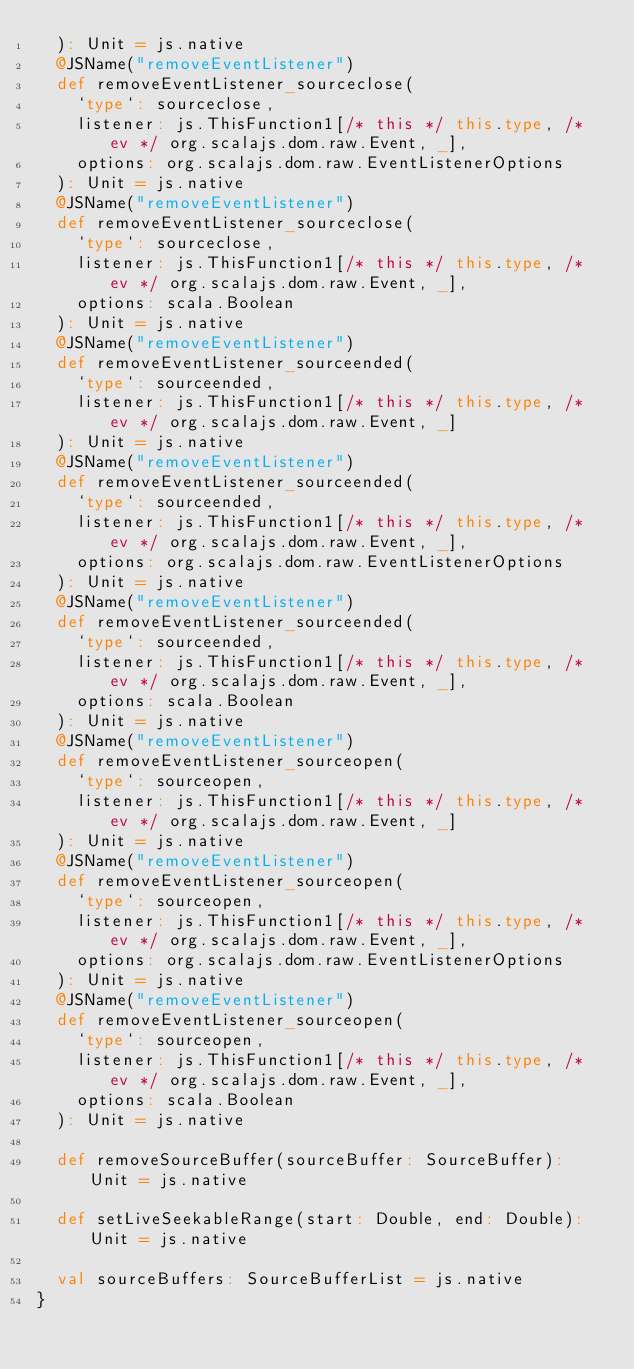<code> <loc_0><loc_0><loc_500><loc_500><_Scala_>  ): Unit = js.native
  @JSName("removeEventListener")
  def removeEventListener_sourceclose(
    `type`: sourceclose,
    listener: js.ThisFunction1[/* this */ this.type, /* ev */ org.scalajs.dom.raw.Event, _],
    options: org.scalajs.dom.raw.EventListenerOptions
  ): Unit = js.native
  @JSName("removeEventListener")
  def removeEventListener_sourceclose(
    `type`: sourceclose,
    listener: js.ThisFunction1[/* this */ this.type, /* ev */ org.scalajs.dom.raw.Event, _],
    options: scala.Boolean
  ): Unit = js.native
  @JSName("removeEventListener")
  def removeEventListener_sourceended(
    `type`: sourceended,
    listener: js.ThisFunction1[/* this */ this.type, /* ev */ org.scalajs.dom.raw.Event, _]
  ): Unit = js.native
  @JSName("removeEventListener")
  def removeEventListener_sourceended(
    `type`: sourceended,
    listener: js.ThisFunction1[/* this */ this.type, /* ev */ org.scalajs.dom.raw.Event, _],
    options: org.scalajs.dom.raw.EventListenerOptions
  ): Unit = js.native
  @JSName("removeEventListener")
  def removeEventListener_sourceended(
    `type`: sourceended,
    listener: js.ThisFunction1[/* this */ this.type, /* ev */ org.scalajs.dom.raw.Event, _],
    options: scala.Boolean
  ): Unit = js.native
  @JSName("removeEventListener")
  def removeEventListener_sourceopen(
    `type`: sourceopen,
    listener: js.ThisFunction1[/* this */ this.type, /* ev */ org.scalajs.dom.raw.Event, _]
  ): Unit = js.native
  @JSName("removeEventListener")
  def removeEventListener_sourceopen(
    `type`: sourceopen,
    listener: js.ThisFunction1[/* this */ this.type, /* ev */ org.scalajs.dom.raw.Event, _],
    options: org.scalajs.dom.raw.EventListenerOptions
  ): Unit = js.native
  @JSName("removeEventListener")
  def removeEventListener_sourceopen(
    `type`: sourceopen,
    listener: js.ThisFunction1[/* this */ this.type, /* ev */ org.scalajs.dom.raw.Event, _],
    options: scala.Boolean
  ): Unit = js.native
  
  def removeSourceBuffer(sourceBuffer: SourceBuffer): Unit = js.native
  
  def setLiveSeekableRange(start: Double, end: Double): Unit = js.native
  
  val sourceBuffers: SourceBufferList = js.native
}
</code> 